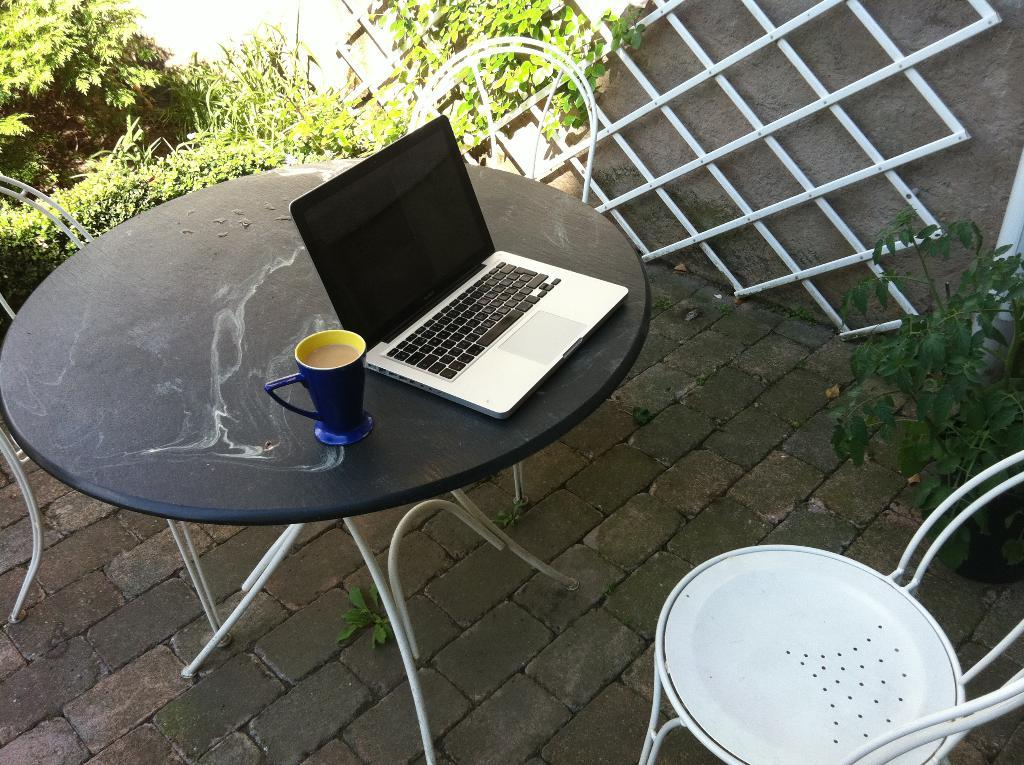What piece of furniture is in the image? There is a table in the image. What electronic device is on the table? A laptop is present on the table. What beverage is on the table? There is a cup of coffee on the table. What is the person sitting on in front of the table? A chair is in front of the table. What type of greenery is visible in the image? Plants are visible in the image. What verse is being recited by the marble statue in the image? There is no marble statue or verse present in the image. How many mines are visible in the image? There are no mines visible in the image. 